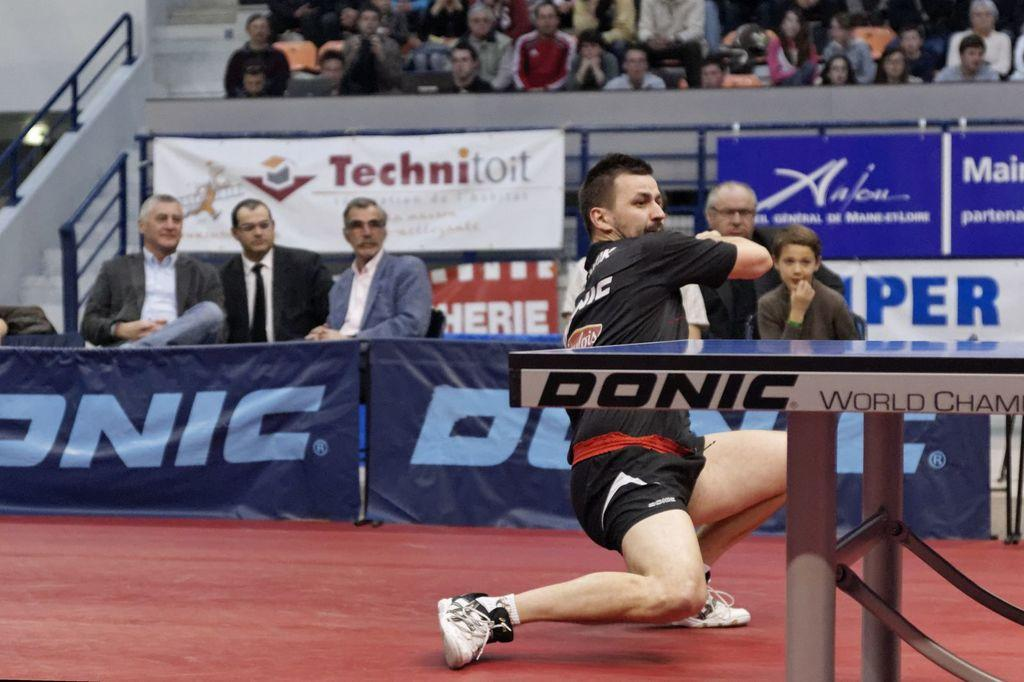What is the man in the image doing? The man is playing a game in the image. Where are the people located in the image? The people are sitting in the middle of the image. What can be seen in the background of the image? There is an audience in the background of the image. What is on the left side of the image? There is a stair rail on the left side of the image. What type of lock is visible on the wall in the image? There is no lock visible on the wall in the image. What role does the servant play in the image? There is no servant present in the image. 